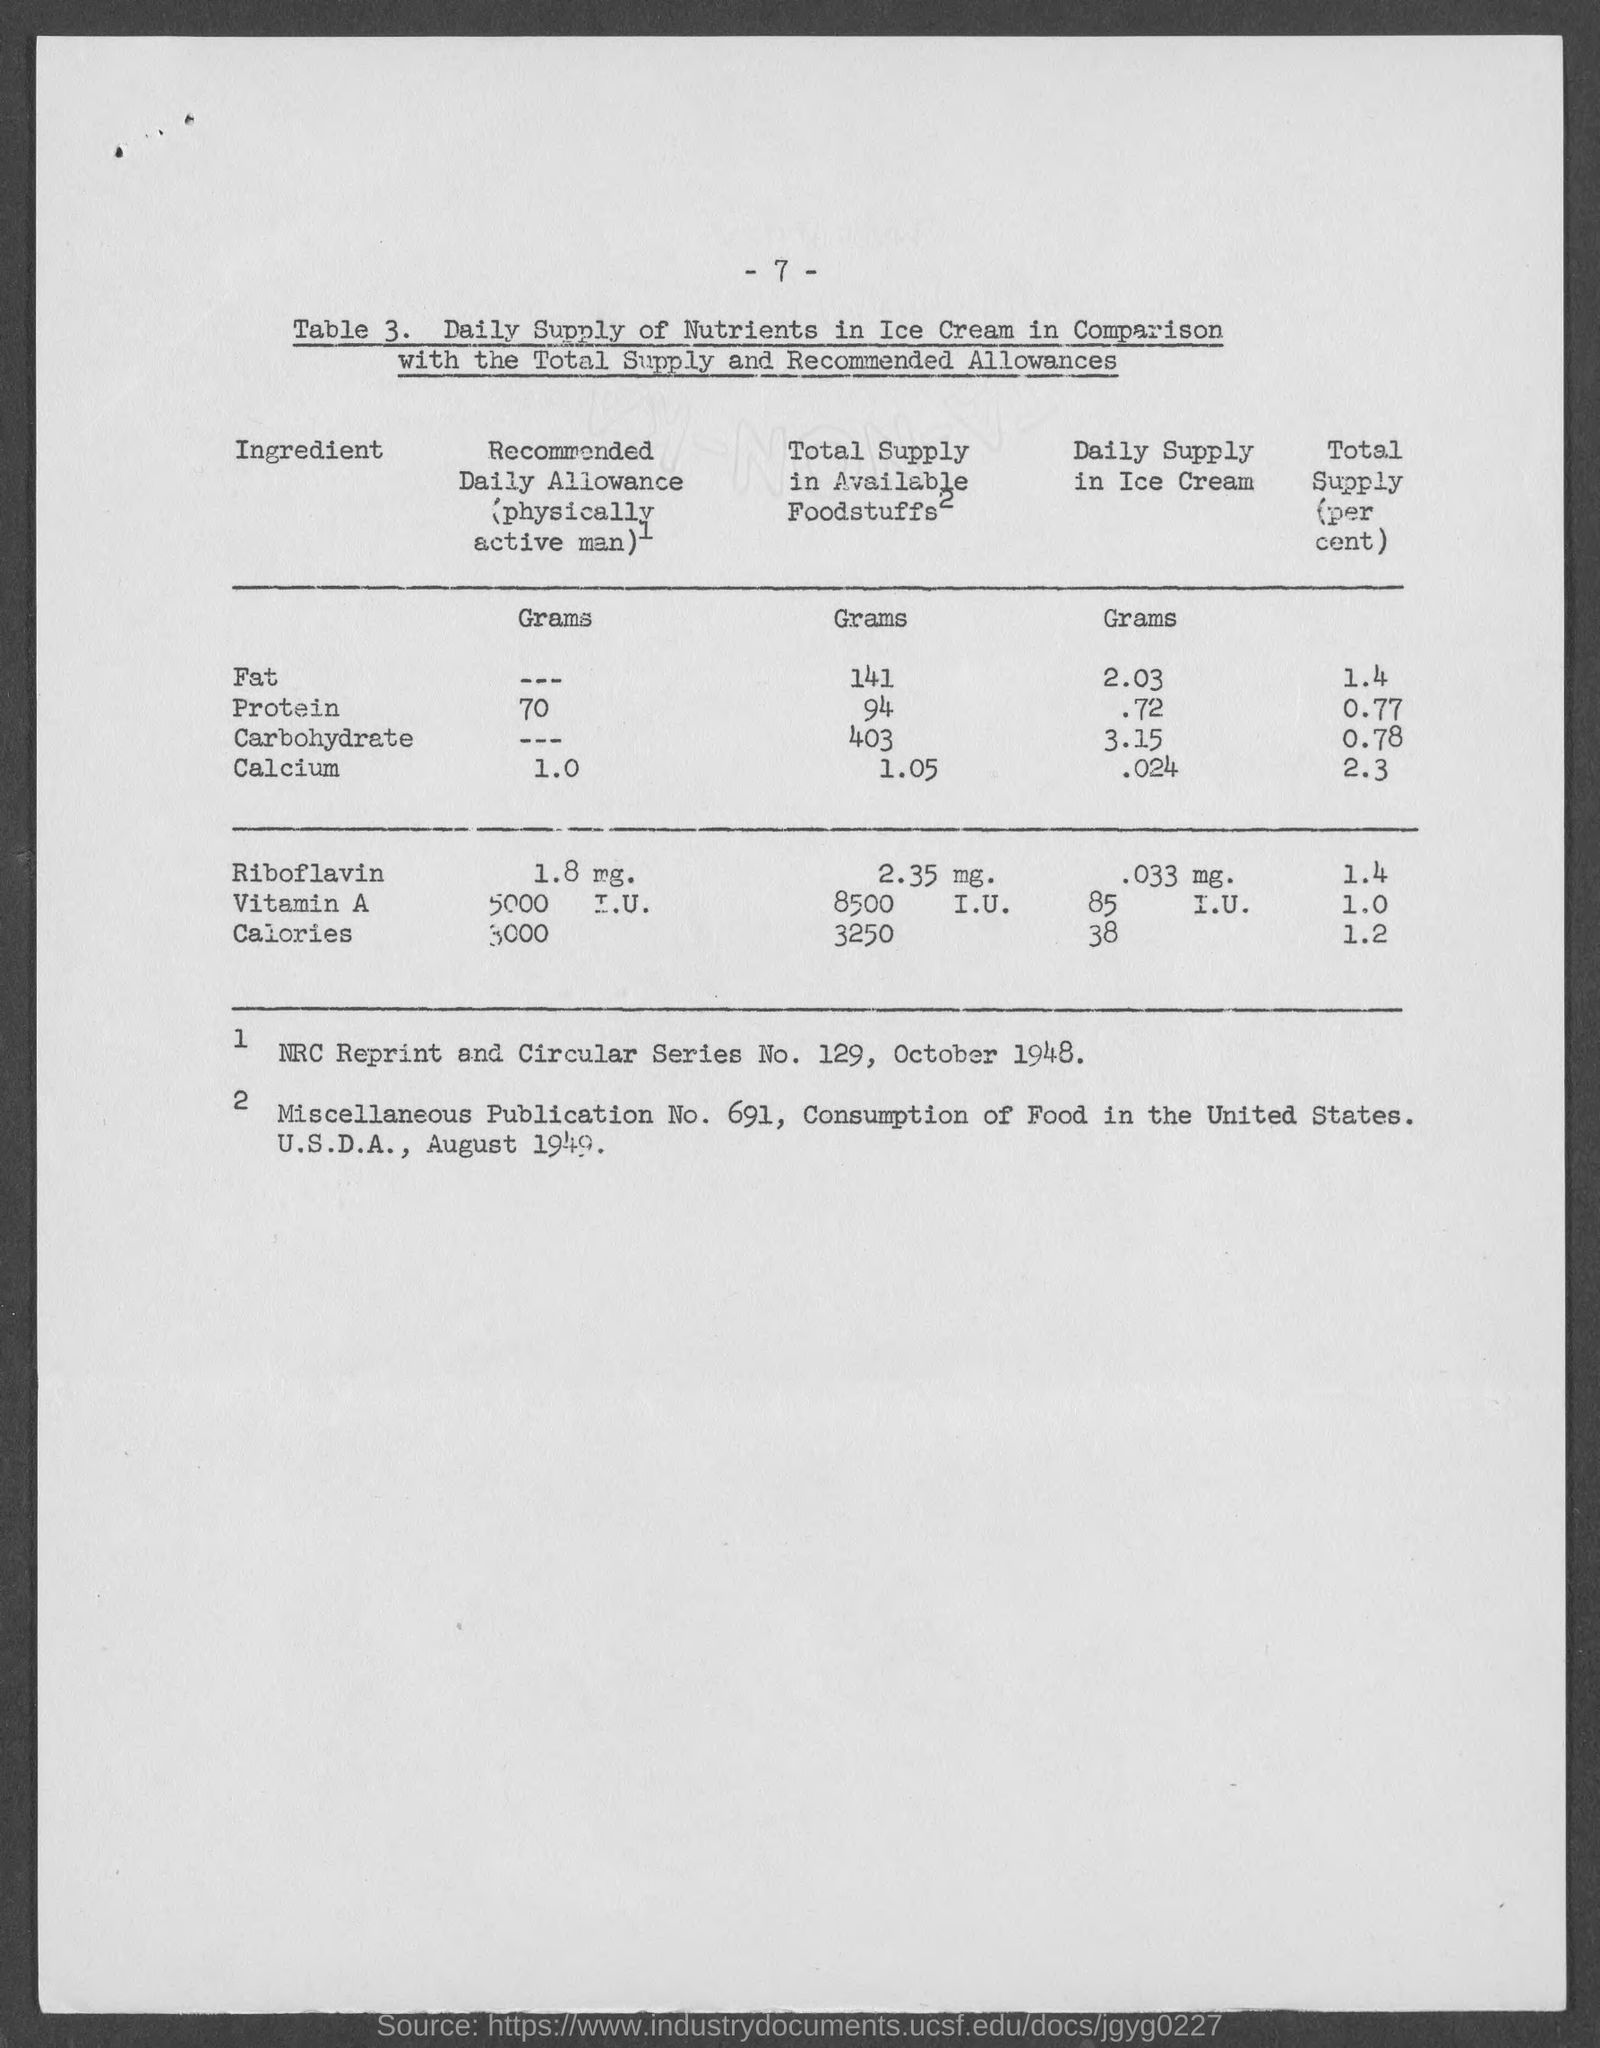Identify some key points in this picture. The number at the top of the page is seven, and I will subtract seven from it. 